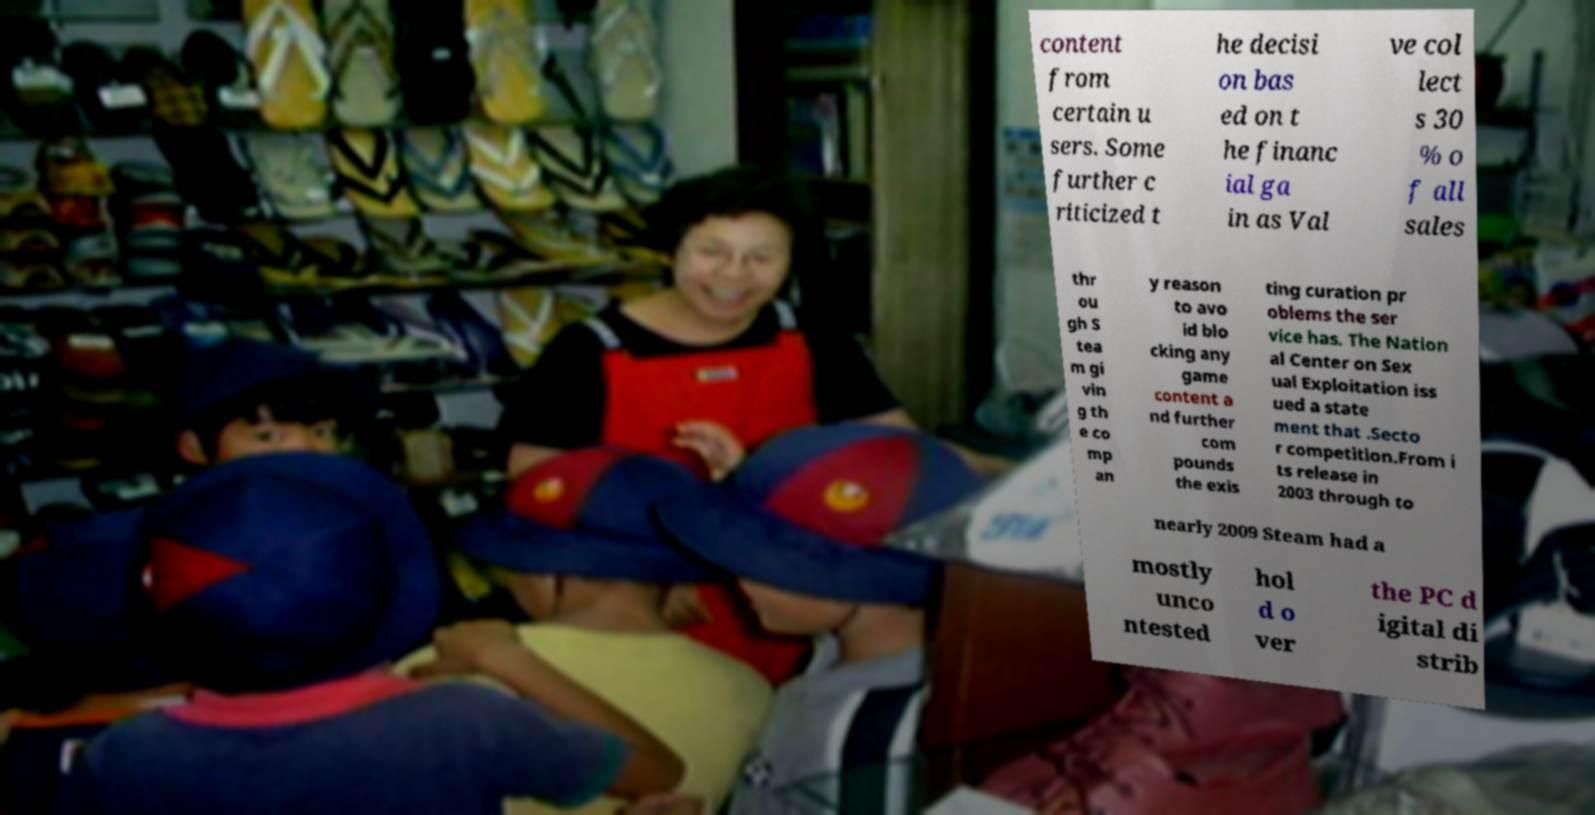There's text embedded in this image that I need extracted. Can you transcribe it verbatim? content from certain u sers. Some further c riticized t he decisi on bas ed on t he financ ial ga in as Val ve col lect s 30 % o f all sales thr ou gh S tea m gi vin g th e co mp an y reason to avo id blo cking any game content a nd further com pounds the exis ting curation pr oblems the ser vice has. The Nation al Center on Sex ual Exploitation iss ued a state ment that .Secto r competition.From i ts release in 2003 through to nearly 2009 Steam had a mostly unco ntested hol d o ver the PC d igital di strib 